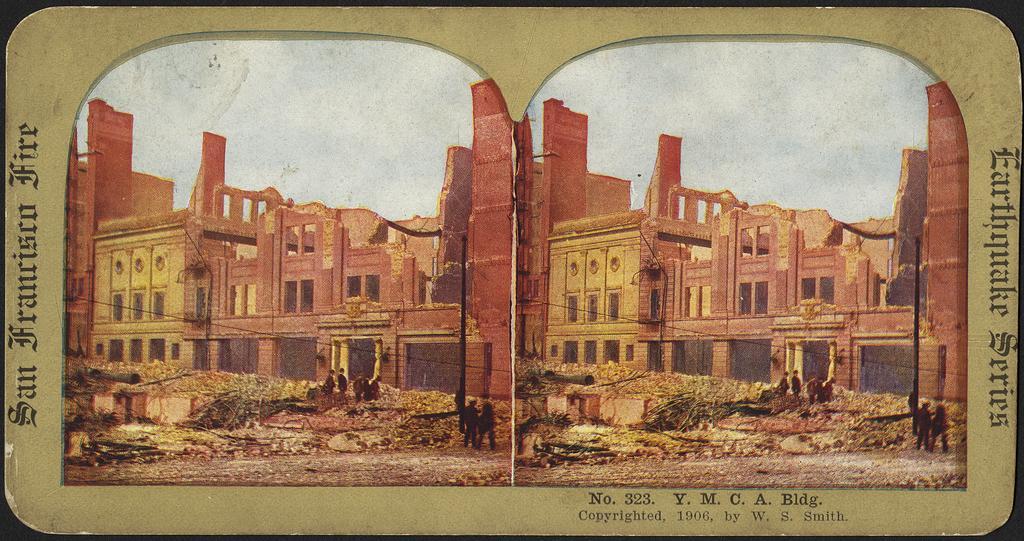Could you give a brief overview of what you see in this image? In this image there is a poster. In which there are buildings and there is some text at the bottom of the image. 